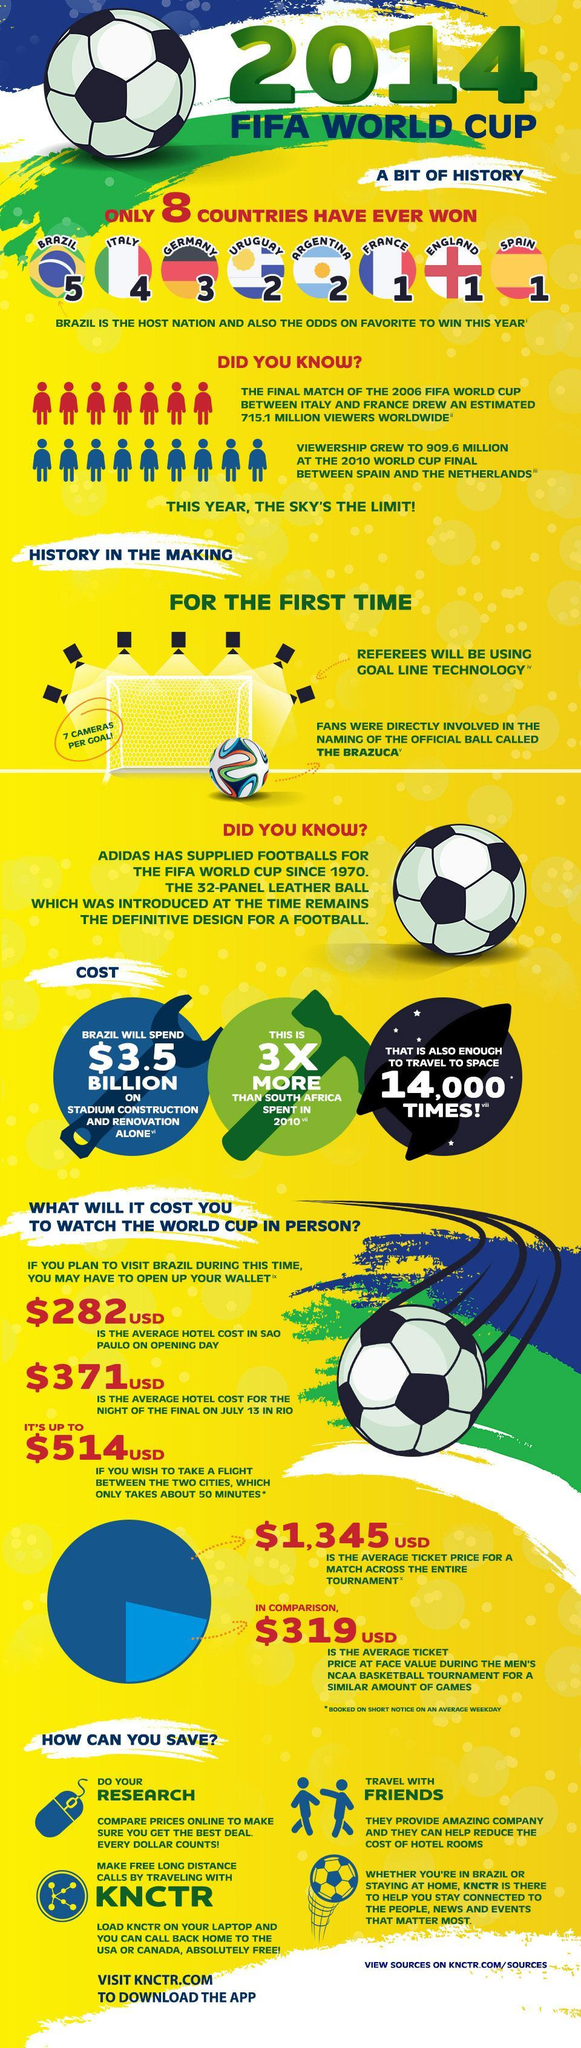What will be the total average hotel cost in USD on the opening day in Sao Paulo and the night of the final in Rio
Answer the question with a short phrase. 653 WHich countries have won the FIFA World cup 2 times Uruguay, Argentina, What is the cost for travelling to space 14000 times $3.5 billion WHich countries have won the FIFA World cup once France, England, Spain What has been the increase in viewers in millions from 2006 to 2010 194.5 